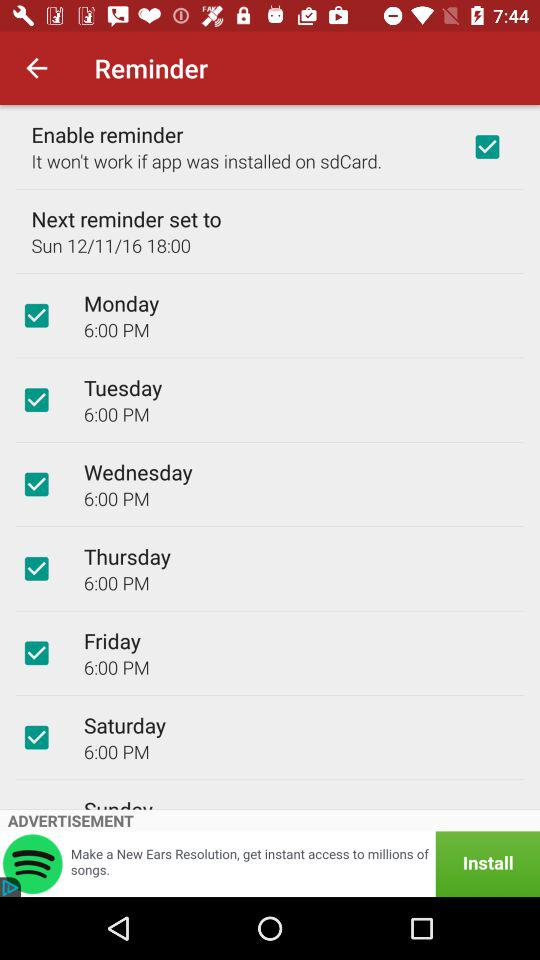What day on 12/11/16? The day is Sunday. 